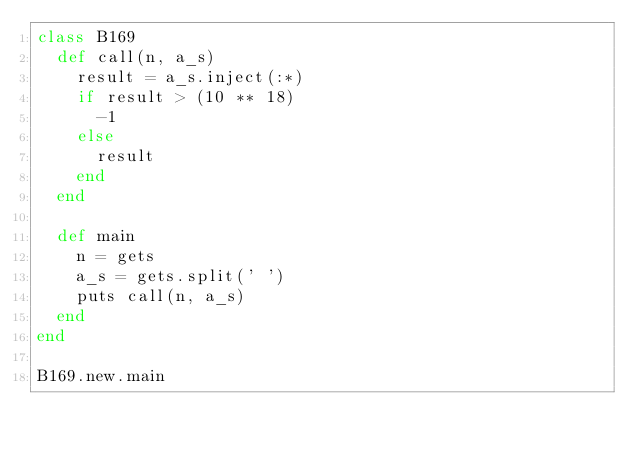Convert code to text. <code><loc_0><loc_0><loc_500><loc_500><_Ruby_>class B169
  def call(n, a_s)
    result = a_s.inject(:*)
    if result > (10 ** 18)
      -1
    else
      result
    end
  end

  def main
    n = gets
    a_s = gets.split(' ')
    puts call(n, a_s)
  end
end

B169.new.main</code> 